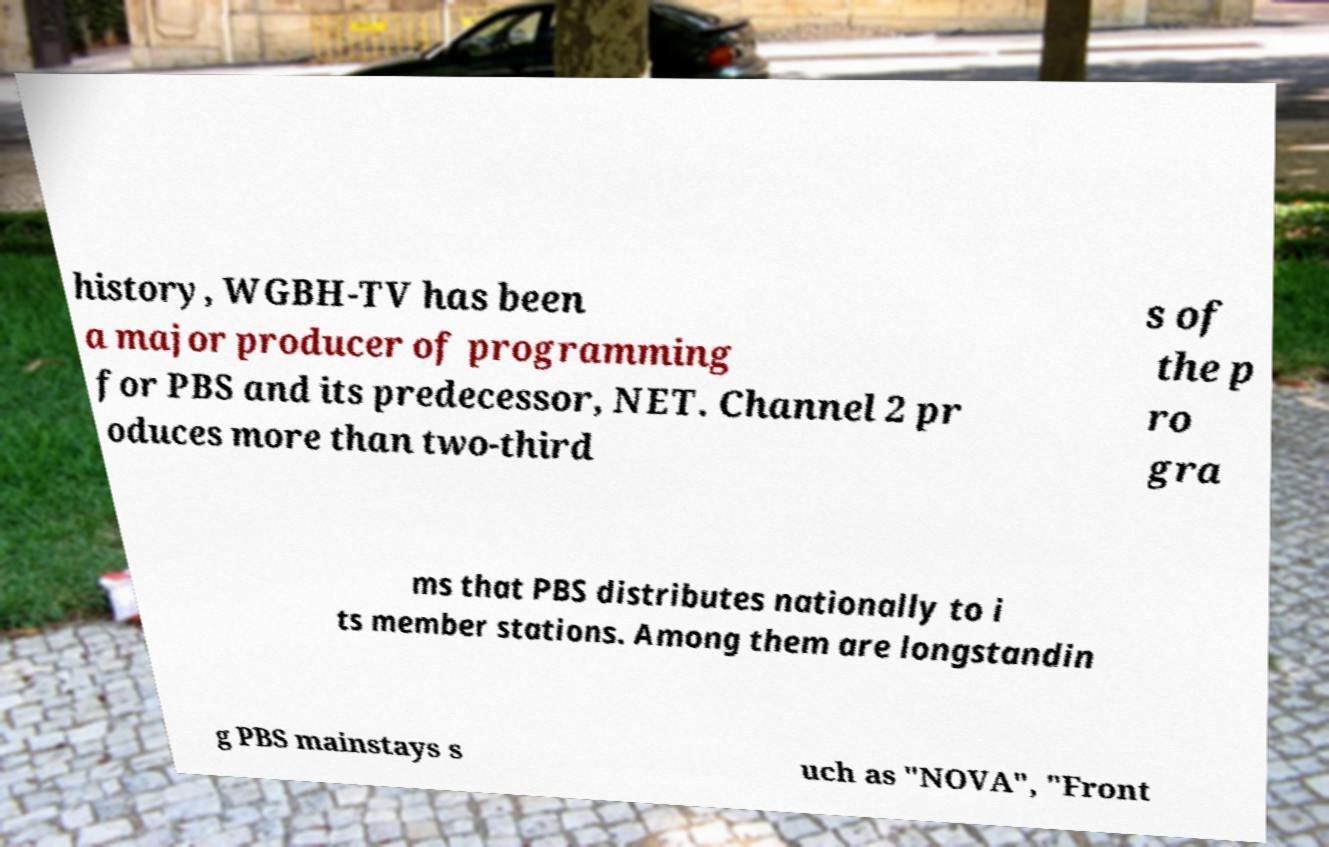Can you read and provide the text displayed in the image?This photo seems to have some interesting text. Can you extract and type it out for me? history, WGBH-TV has been a major producer of programming for PBS and its predecessor, NET. Channel 2 pr oduces more than two-third s of the p ro gra ms that PBS distributes nationally to i ts member stations. Among them are longstandin g PBS mainstays s uch as "NOVA", "Front 